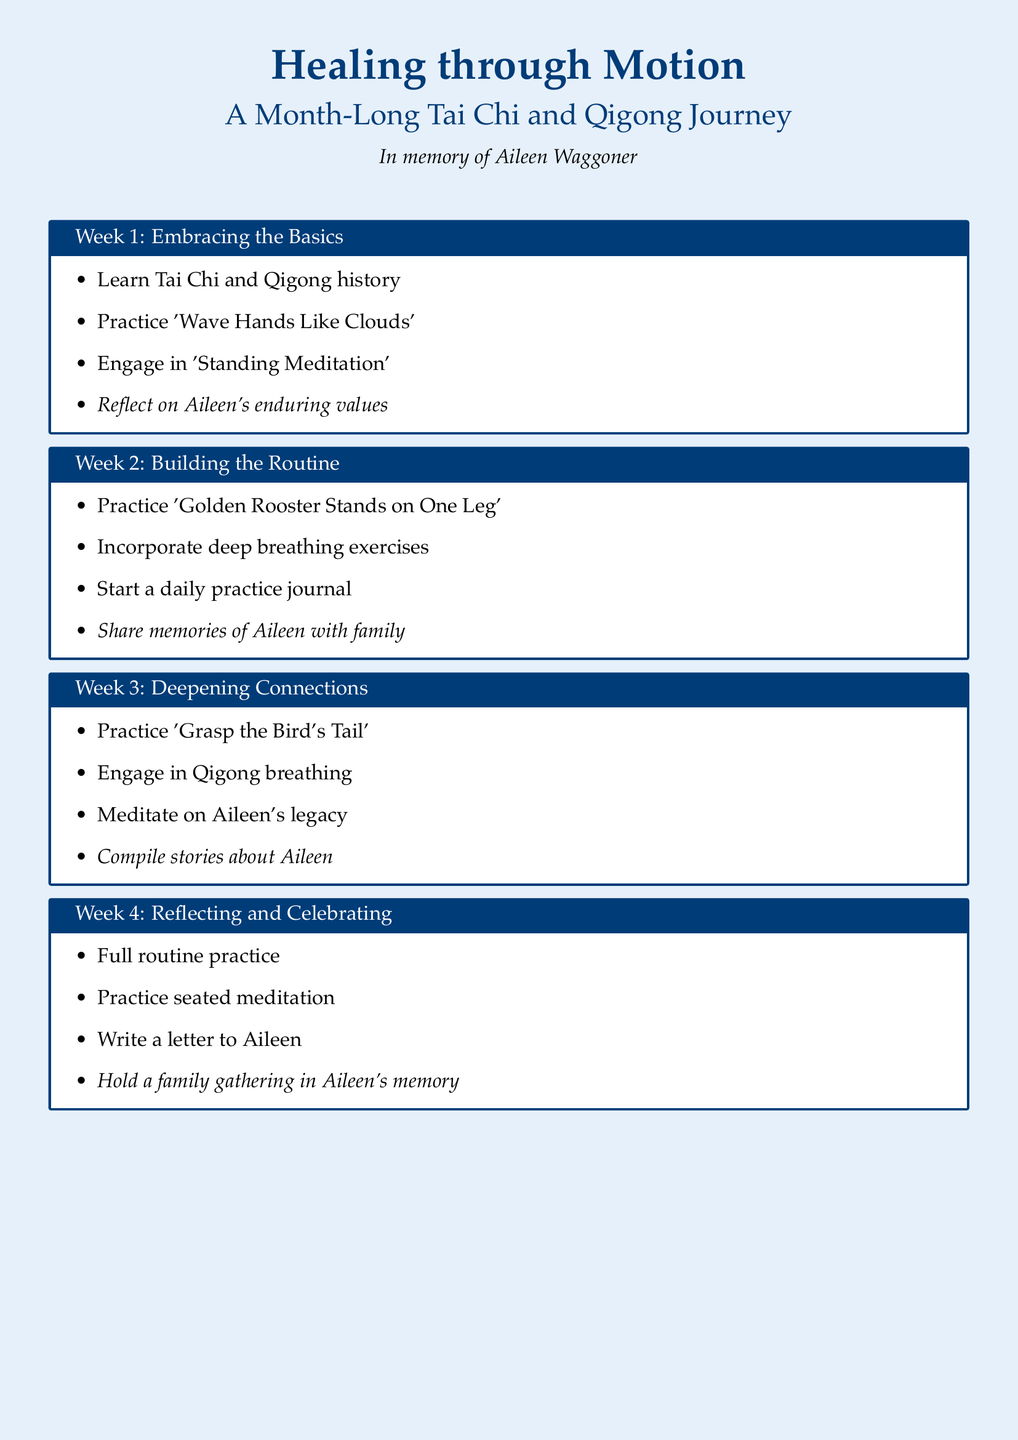What is the title of the document? The title of the document is prominently displayed at the top.
Answer: Healing through Motion Who is the document dedicated to? The dedication is mentioned under the title, noting who the document is in memory of.
Answer: Aileen Waggoner How many weeks does the workout plan cover? The document is structured around a specific number of weeks for the practice.
Answer: 4 What is the focus of Week 1? The main activities of the first week are outlined in the respective section.
Answer: Embracing the Basics What practice involves breathing exercises? The document highlights a week focused on building a routine, which includes this activity.
Answer: Week 2 What reflective activity is suggested for Week 4? The document mentions a specific reflective action to take in the final week.
Answer: Write a letter to Aileen What is one tip provided in the Tips & Resources section? The tips section includes brief recommendations for enhancing practice.
Answer: Be consistent with daily practice Which resource is suggested for learning about Tai Chi? The document lists a specific book as a resource for Tai Chi practice.
Answer: "The Art of Tai Chi" by Master Yang Chengfu 